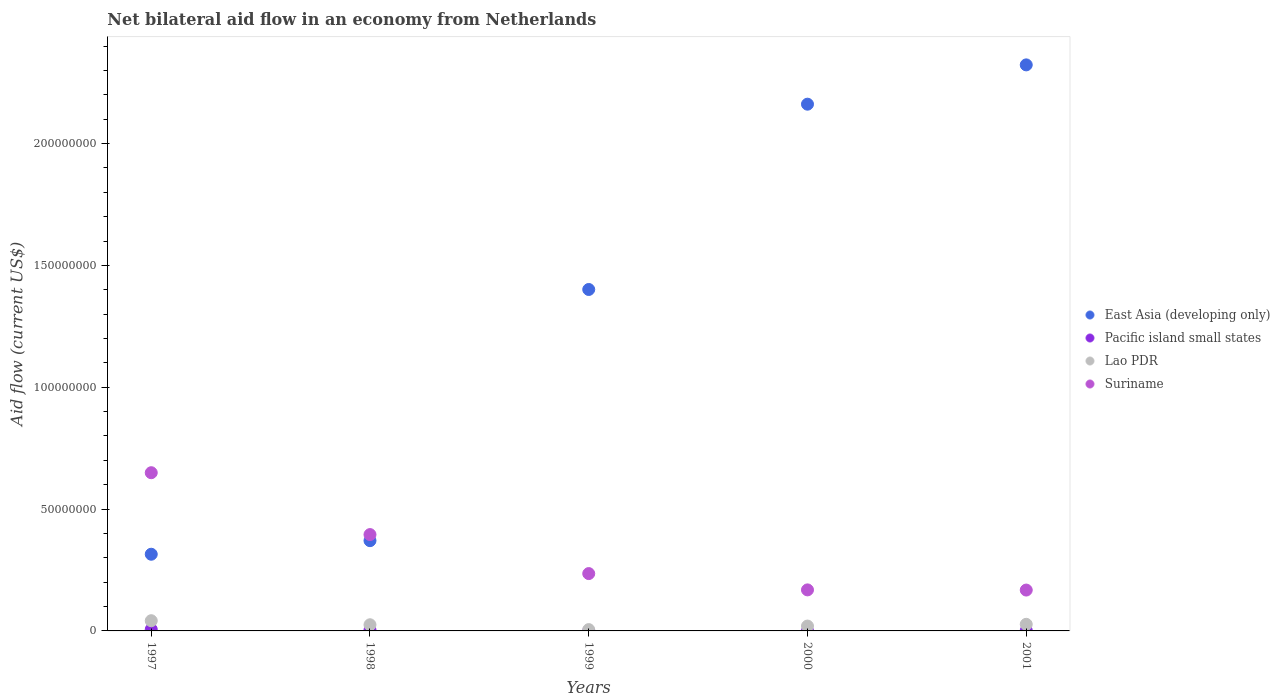What is the net bilateral aid flow in Suriname in 1998?
Make the answer very short. 3.95e+07. Across all years, what is the maximum net bilateral aid flow in Lao PDR?
Provide a short and direct response. 4.19e+06. Across all years, what is the minimum net bilateral aid flow in East Asia (developing only)?
Keep it short and to the point. 3.15e+07. What is the total net bilateral aid flow in Pacific island small states in the graph?
Provide a short and direct response. 1.22e+06. What is the difference between the net bilateral aid flow in Suriname in 1999 and that in 2000?
Your answer should be compact. 6.69e+06. What is the difference between the net bilateral aid flow in Pacific island small states in 1998 and the net bilateral aid flow in Suriname in 1999?
Provide a succinct answer. -2.31e+07. What is the average net bilateral aid flow in East Asia (developing only) per year?
Offer a terse response. 1.31e+08. In the year 1998, what is the difference between the net bilateral aid flow in Lao PDR and net bilateral aid flow in Suriname?
Your answer should be very brief. -3.70e+07. Is the difference between the net bilateral aid flow in Lao PDR in 1998 and 2000 greater than the difference between the net bilateral aid flow in Suriname in 1998 and 2000?
Give a very brief answer. No. What is the difference between the highest and the second highest net bilateral aid flow in Suriname?
Make the answer very short. 2.54e+07. What is the difference between the highest and the lowest net bilateral aid flow in Lao PDR?
Ensure brevity in your answer.  3.65e+06. In how many years, is the net bilateral aid flow in Suriname greater than the average net bilateral aid flow in Suriname taken over all years?
Your response must be concise. 2. Is it the case that in every year, the sum of the net bilateral aid flow in Lao PDR and net bilateral aid flow in Pacific island small states  is greater than the sum of net bilateral aid flow in Suriname and net bilateral aid flow in East Asia (developing only)?
Provide a succinct answer. No. Is the net bilateral aid flow in Suriname strictly greater than the net bilateral aid flow in Pacific island small states over the years?
Your response must be concise. Yes. Is the net bilateral aid flow in Pacific island small states strictly less than the net bilateral aid flow in Lao PDR over the years?
Your response must be concise. Yes. How many dotlines are there?
Give a very brief answer. 4. How many years are there in the graph?
Your answer should be very brief. 5. Are the values on the major ticks of Y-axis written in scientific E-notation?
Keep it short and to the point. No. Does the graph contain any zero values?
Give a very brief answer. Yes. Where does the legend appear in the graph?
Provide a short and direct response. Center right. What is the title of the graph?
Offer a very short reply. Net bilateral aid flow in an economy from Netherlands. Does "Mongolia" appear as one of the legend labels in the graph?
Offer a terse response. No. What is the label or title of the X-axis?
Make the answer very short. Years. What is the Aid flow (current US$) of East Asia (developing only) in 1997?
Your answer should be very brief. 3.15e+07. What is the Aid flow (current US$) in Pacific island small states in 1997?
Your answer should be very brief. 6.20e+05. What is the Aid flow (current US$) of Lao PDR in 1997?
Your answer should be compact. 4.19e+06. What is the Aid flow (current US$) of Suriname in 1997?
Give a very brief answer. 6.49e+07. What is the Aid flow (current US$) in East Asia (developing only) in 1998?
Offer a terse response. 3.70e+07. What is the Aid flow (current US$) in Lao PDR in 1998?
Your answer should be compact. 2.53e+06. What is the Aid flow (current US$) of Suriname in 1998?
Your answer should be compact. 3.95e+07. What is the Aid flow (current US$) of East Asia (developing only) in 1999?
Keep it short and to the point. 1.40e+08. What is the Aid flow (current US$) in Lao PDR in 1999?
Give a very brief answer. 5.40e+05. What is the Aid flow (current US$) of Suriname in 1999?
Keep it short and to the point. 2.35e+07. What is the Aid flow (current US$) of East Asia (developing only) in 2000?
Your answer should be very brief. 2.16e+08. What is the Aid flow (current US$) in Pacific island small states in 2000?
Offer a very short reply. 3.00e+04. What is the Aid flow (current US$) in Lao PDR in 2000?
Give a very brief answer. 1.99e+06. What is the Aid flow (current US$) of Suriname in 2000?
Make the answer very short. 1.68e+07. What is the Aid flow (current US$) of East Asia (developing only) in 2001?
Make the answer very short. 2.32e+08. What is the Aid flow (current US$) in Lao PDR in 2001?
Offer a very short reply. 2.71e+06. What is the Aid flow (current US$) in Suriname in 2001?
Offer a terse response. 1.68e+07. Across all years, what is the maximum Aid flow (current US$) of East Asia (developing only)?
Your answer should be very brief. 2.32e+08. Across all years, what is the maximum Aid flow (current US$) of Pacific island small states?
Keep it short and to the point. 6.20e+05. Across all years, what is the maximum Aid flow (current US$) of Lao PDR?
Offer a terse response. 4.19e+06. Across all years, what is the maximum Aid flow (current US$) in Suriname?
Provide a succinct answer. 6.49e+07. Across all years, what is the minimum Aid flow (current US$) of East Asia (developing only)?
Your response must be concise. 3.15e+07. Across all years, what is the minimum Aid flow (current US$) in Lao PDR?
Provide a short and direct response. 5.40e+05. Across all years, what is the minimum Aid flow (current US$) of Suriname?
Keep it short and to the point. 1.68e+07. What is the total Aid flow (current US$) in East Asia (developing only) in the graph?
Provide a short and direct response. 6.57e+08. What is the total Aid flow (current US$) in Pacific island small states in the graph?
Ensure brevity in your answer.  1.22e+06. What is the total Aid flow (current US$) of Lao PDR in the graph?
Ensure brevity in your answer.  1.20e+07. What is the total Aid flow (current US$) of Suriname in the graph?
Give a very brief answer. 1.62e+08. What is the difference between the Aid flow (current US$) of East Asia (developing only) in 1997 and that in 1998?
Offer a very short reply. -5.57e+06. What is the difference between the Aid flow (current US$) of Pacific island small states in 1997 and that in 1998?
Provide a succinct answer. 2.30e+05. What is the difference between the Aid flow (current US$) in Lao PDR in 1997 and that in 1998?
Your answer should be compact. 1.66e+06. What is the difference between the Aid flow (current US$) of Suriname in 1997 and that in 1998?
Your answer should be compact. 2.54e+07. What is the difference between the Aid flow (current US$) of East Asia (developing only) in 1997 and that in 1999?
Give a very brief answer. -1.09e+08. What is the difference between the Aid flow (current US$) of Lao PDR in 1997 and that in 1999?
Provide a short and direct response. 3.65e+06. What is the difference between the Aid flow (current US$) in Suriname in 1997 and that in 1999?
Keep it short and to the point. 4.14e+07. What is the difference between the Aid flow (current US$) of East Asia (developing only) in 1997 and that in 2000?
Provide a succinct answer. -1.85e+08. What is the difference between the Aid flow (current US$) in Pacific island small states in 1997 and that in 2000?
Provide a succinct answer. 5.90e+05. What is the difference between the Aid flow (current US$) of Lao PDR in 1997 and that in 2000?
Make the answer very short. 2.20e+06. What is the difference between the Aid flow (current US$) in Suriname in 1997 and that in 2000?
Offer a terse response. 4.81e+07. What is the difference between the Aid flow (current US$) in East Asia (developing only) in 1997 and that in 2001?
Your answer should be compact. -2.01e+08. What is the difference between the Aid flow (current US$) of Pacific island small states in 1997 and that in 2001?
Provide a succinct answer. 4.40e+05. What is the difference between the Aid flow (current US$) of Lao PDR in 1997 and that in 2001?
Keep it short and to the point. 1.48e+06. What is the difference between the Aid flow (current US$) of Suriname in 1997 and that in 2001?
Keep it short and to the point. 4.82e+07. What is the difference between the Aid flow (current US$) in East Asia (developing only) in 1998 and that in 1999?
Offer a terse response. -1.03e+08. What is the difference between the Aid flow (current US$) in Lao PDR in 1998 and that in 1999?
Make the answer very short. 1.99e+06. What is the difference between the Aid flow (current US$) of Suriname in 1998 and that in 1999?
Provide a succinct answer. 1.60e+07. What is the difference between the Aid flow (current US$) of East Asia (developing only) in 1998 and that in 2000?
Your response must be concise. -1.79e+08. What is the difference between the Aid flow (current US$) in Pacific island small states in 1998 and that in 2000?
Offer a terse response. 3.60e+05. What is the difference between the Aid flow (current US$) in Lao PDR in 1998 and that in 2000?
Your answer should be compact. 5.40e+05. What is the difference between the Aid flow (current US$) in Suriname in 1998 and that in 2000?
Make the answer very short. 2.27e+07. What is the difference between the Aid flow (current US$) in East Asia (developing only) in 1998 and that in 2001?
Give a very brief answer. -1.95e+08. What is the difference between the Aid flow (current US$) of Suriname in 1998 and that in 2001?
Your answer should be very brief. 2.28e+07. What is the difference between the Aid flow (current US$) of East Asia (developing only) in 1999 and that in 2000?
Your answer should be very brief. -7.60e+07. What is the difference between the Aid flow (current US$) of Lao PDR in 1999 and that in 2000?
Your answer should be very brief. -1.45e+06. What is the difference between the Aid flow (current US$) in Suriname in 1999 and that in 2000?
Your answer should be compact. 6.69e+06. What is the difference between the Aid flow (current US$) in East Asia (developing only) in 1999 and that in 2001?
Provide a short and direct response. -9.22e+07. What is the difference between the Aid flow (current US$) of Lao PDR in 1999 and that in 2001?
Provide a succinct answer. -2.17e+06. What is the difference between the Aid flow (current US$) of Suriname in 1999 and that in 2001?
Your response must be concise. 6.76e+06. What is the difference between the Aid flow (current US$) in East Asia (developing only) in 2000 and that in 2001?
Ensure brevity in your answer.  -1.61e+07. What is the difference between the Aid flow (current US$) of Pacific island small states in 2000 and that in 2001?
Provide a succinct answer. -1.50e+05. What is the difference between the Aid flow (current US$) in Lao PDR in 2000 and that in 2001?
Offer a terse response. -7.20e+05. What is the difference between the Aid flow (current US$) of East Asia (developing only) in 1997 and the Aid flow (current US$) of Pacific island small states in 1998?
Offer a very short reply. 3.11e+07. What is the difference between the Aid flow (current US$) in East Asia (developing only) in 1997 and the Aid flow (current US$) in Lao PDR in 1998?
Provide a succinct answer. 2.89e+07. What is the difference between the Aid flow (current US$) of East Asia (developing only) in 1997 and the Aid flow (current US$) of Suriname in 1998?
Give a very brief answer. -8.07e+06. What is the difference between the Aid flow (current US$) in Pacific island small states in 1997 and the Aid flow (current US$) in Lao PDR in 1998?
Your answer should be very brief. -1.91e+06. What is the difference between the Aid flow (current US$) in Pacific island small states in 1997 and the Aid flow (current US$) in Suriname in 1998?
Provide a short and direct response. -3.89e+07. What is the difference between the Aid flow (current US$) of Lao PDR in 1997 and the Aid flow (current US$) of Suriname in 1998?
Your answer should be very brief. -3.54e+07. What is the difference between the Aid flow (current US$) in East Asia (developing only) in 1997 and the Aid flow (current US$) in Lao PDR in 1999?
Your answer should be compact. 3.09e+07. What is the difference between the Aid flow (current US$) in East Asia (developing only) in 1997 and the Aid flow (current US$) in Suriname in 1999?
Your answer should be compact. 7.94e+06. What is the difference between the Aid flow (current US$) in Pacific island small states in 1997 and the Aid flow (current US$) in Lao PDR in 1999?
Keep it short and to the point. 8.00e+04. What is the difference between the Aid flow (current US$) in Pacific island small states in 1997 and the Aid flow (current US$) in Suriname in 1999?
Keep it short and to the point. -2.29e+07. What is the difference between the Aid flow (current US$) of Lao PDR in 1997 and the Aid flow (current US$) of Suriname in 1999?
Offer a terse response. -1.93e+07. What is the difference between the Aid flow (current US$) of East Asia (developing only) in 1997 and the Aid flow (current US$) of Pacific island small states in 2000?
Your answer should be very brief. 3.14e+07. What is the difference between the Aid flow (current US$) in East Asia (developing only) in 1997 and the Aid flow (current US$) in Lao PDR in 2000?
Ensure brevity in your answer.  2.95e+07. What is the difference between the Aid flow (current US$) of East Asia (developing only) in 1997 and the Aid flow (current US$) of Suriname in 2000?
Your response must be concise. 1.46e+07. What is the difference between the Aid flow (current US$) of Pacific island small states in 1997 and the Aid flow (current US$) of Lao PDR in 2000?
Your answer should be compact. -1.37e+06. What is the difference between the Aid flow (current US$) of Pacific island small states in 1997 and the Aid flow (current US$) of Suriname in 2000?
Your answer should be very brief. -1.62e+07. What is the difference between the Aid flow (current US$) of Lao PDR in 1997 and the Aid flow (current US$) of Suriname in 2000?
Make the answer very short. -1.26e+07. What is the difference between the Aid flow (current US$) of East Asia (developing only) in 1997 and the Aid flow (current US$) of Pacific island small states in 2001?
Offer a very short reply. 3.13e+07. What is the difference between the Aid flow (current US$) of East Asia (developing only) in 1997 and the Aid flow (current US$) of Lao PDR in 2001?
Provide a short and direct response. 2.88e+07. What is the difference between the Aid flow (current US$) in East Asia (developing only) in 1997 and the Aid flow (current US$) in Suriname in 2001?
Your response must be concise. 1.47e+07. What is the difference between the Aid flow (current US$) in Pacific island small states in 1997 and the Aid flow (current US$) in Lao PDR in 2001?
Offer a very short reply. -2.09e+06. What is the difference between the Aid flow (current US$) in Pacific island small states in 1997 and the Aid flow (current US$) in Suriname in 2001?
Provide a short and direct response. -1.62e+07. What is the difference between the Aid flow (current US$) of Lao PDR in 1997 and the Aid flow (current US$) of Suriname in 2001?
Keep it short and to the point. -1.26e+07. What is the difference between the Aid flow (current US$) of East Asia (developing only) in 1998 and the Aid flow (current US$) of Lao PDR in 1999?
Ensure brevity in your answer.  3.65e+07. What is the difference between the Aid flow (current US$) in East Asia (developing only) in 1998 and the Aid flow (current US$) in Suriname in 1999?
Keep it short and to the point. 1.35e+07. What is the difference between the Aid flow (current US$) of Pacific island small states in 1998 and the Aid flow (current US$) of Lao PDR in 1999?
Keep it short and to the point. -1.50e+05. What is the difference between the Aid flow (current US$) of Pacific island small states in 1998 and the Aid flow (current US$) of Suriname in 1999?
Provide a short and direct response. -2.31e+07. What is the difference between the Aid flow (current US$) of Lao PDR in 1998 and the Aid flow (current US$) of Suriname in 1999?
Your answer should be very brief. -2.10e+07. What is the difference between the Aid flow (current US$) in East Asia (developing only) in 1998 and the Aid flow (current US$) in Pacific island small states in 2000?
Offer a terse response. 3.70e+07. What is the difference between the Aid flow (current US$) in East Asia (developing only) in 1998 and the Aid flow (current US$) in Lao PDR in 2000?
Offer a very short reply. 3.50e+07. What is the difference between the Aid flow (current US$) in East Asia (developing only) in 1998 and the Aid flow (current US$) in Suriname in 2000?
Your answer should be compact. 2.02e+07. What is the difference between the Aid flow (current US$) in Pacific island small states in 1998 and the Aid flow (current US$) in Lao PDR in 2000?
Your answer should be compact. -1.60e+06. What is the difference between the Aid flow (current US$) in Pacific island small states in 1998 and the Aid flow (current US$) in Suriname in 2000?
Make the answer very short. -1.64e+07. What is the difference between the Aid flow (current US$) in Lao PDR in 1998 and the Aid flow (current US$) in Suriname in 2000?
Ensure brevity in your answer.  -1.43e+07. What is the difference between the Aid flow (current US$) of East Asia (developing only) in 1998 and the Aid flow (current US$) of Pacific island small states in 2001?
Your answer should be compact. 3.69e+07. What is the difference between the Aid flow (current US$) of East Asia (developing only) in 1998 and the Aid flow (current US$) of Lao PDR in 2001?
Keep it short and to the point. 3.43e+07. What is the difference between the Aid flow (current US$) in East Asia (developing only) in 1998 and the Aid flow (current US$) in Suriname in 2001?
Make the answer very short. 2.03e+07. What is the difference between the Aid flow (current US$) of Pacific island small states in 1998 and the Aid flow (current US$) of Lao PDR in 2001?
Your answer should be compact. -2.32e+06. What is the difference between the Aid flow (current US$) in Pacific island small states in 1998 and the Aid flow (current US$) in Suriname in 2001?
Your answer should be compact. -1.64e+07. What is the difference between the Aid flow (current US$) of Lao PDR in 1998 and the Aid flow (current US$) of Suriname in 2001?
Make the answer very short. -1.42e+07. What is the difference between the Aid flow (current US$) in East Asia (developing only) in 1999 and the Aid flow (current US$) in Pacific island small states in 2000?
Your answer should be compact. 1.40e+08. What is the difference between the Aid flow (current US$) in East Asia (developing only) in 1999 and the Aid flow (current US$) in Lao PDR in 2000?
Give a very brief answer. 1.38e+08. What is the difference between the Aid flow (current US$) in East Asia (developing only) in 1999 and the Aid flow (current US$) in Suriname in 2000?
Provide a succinct answer. 1.23e+08. What is the difference between the Aid flow (current US$) of Lao PDR in 1999 and the Aid flow (current US$) of Suriname in 2000?
Offer a very short reply. -1.63e+07. What is the difference between the Aid flow (current US$) in East Asia (developing only) in 1999 and the Aid flow (current US$) in Pacific island small states in 2001?
Provide a succinct answer. 1.40e+08. What is the difference between the Aid flow (current US$) in East Asia (developing only) in 1999 and the Aid flow (current US$) in Lao PDR in 2001?
Give a very brief answer. 1.37e+08. What is the difference between the Aid flow (current US$) of East Asia (developing only) in 1999 and the Aid flow (current US$) of Suriname in 2001?
Your answer should be compact. 1.23e+08. What is the difference between the Aid flow (current US$) in Lao PDR in 1999 and the Aid flow (current US$) in Suriname in 2001?
Your response must be concise. -1.62e+07. What is the difference between the Aid flow (current US$) in East Asia (developing only) in 2000 and the Aid flow (current US$) in Pacific island small states in 2001?
Give a very brief answer. 2.16e+08. What is the difference between the Aid flow (current US$) in East Asia (developing only) in 2000 and the Aid flow (current US$) in Lao PDR in 2001?
Keep it short and to the point. 2.13e+08. What is the difference between the Aid flow (current US$) of East Asia (developing only) in 2000 and the Aid flow (current US$) of Suriname in 2001?
Offer a terse response. 1.99e+08. What is the difference between the Aid flow (current US$) of Pacific island small states in 2000 and the Aid flow (current US$) of Lao PDR in 2001?
Provide a short and direct response. -2.68e+06. What is the difference between the Aid flow (current US$) in Pacific island small states in 2000 and the Aid flow (current US$) in Suriname in 2001?
Provide a short and direct response. -1.67e+07. What is the difference between the Aid flow (current US$) of Lao PDR in 2000 and the Aid flow (current US$) of Suriname in 2001?
Provide a short and direct response. -1.48e+07. What is the average Aid flow (current US$) in East Asia (developing only) per year?
Your answer should be compact. 1.31e+08. What is the average Aid flow (current US$) in Pacific island small states per year?
Provide a short and direct response. 2.44e+05. What is the average Aid flow (current US$) in Lao PDR per year?
Your answer should be compact. 2.39e+06. What is the average Aid flow (current US$) in Suriname per year?
Your answer should be very brief. 3.23e+07. In the year 1997, what is the difference between the Aid flow (current US$) in East Asia (developing only) and Aid flow (current US$) in Pacific island small states?
Ensure brevity in your answer.  3.08e+07. In the year 1997, what is the difference between the Aid flow (current US$) of East Asia (developing only) and Aid flow (current US$) of Lao PDR?
Your answer should be compact. 2.73e+07. In the year 1997, what is the difference between the Aid flow (current US$) of East Asia (developing only) and Aid flow (current US$) of Suriname?
Provide a succinct answer. -3.35e+07. In the year 1997, what is the difference between the Aid flow (current US$) in Pacific island small states and Aid flow (current US$) in Lao PDR?
Your answer should be compact. -3.57e+06. In the year 1997, what is the difference between the Aid flow (current US$) in Pacific island small states and Aid flow (current US$) in Suriname?
Offer a terse response. -6.43e+07. In the year 1997, what is the difference between the Aid flow (current US$) of Lao PDR and Aid flow (current US$) of Suriname?
Keep it short and to the point. -6.07e+07. In the year 1998, what is the difference between the Aid flow (current US$) of East Asia (developing only) and Aid flow (current US$) of Pacific island small states?
Your answer should be very brief. 3.66e+07. In the year 1998, what is the difference between the Aid flow (current US$) in East Asia (developing only) and Aid flow (current US$) in Lao PDR?
Your response must be concise. 3.45e+07. In the year 1998, what is the difference between the Aid flow (current US$) of East Asia (developing only) and Aid flow (current US$) of Suriname?
Offer a terse response. -2.50e+06. In the year 1998, what is the difference between the Aid flow (current US$) in Pacific island small states and Aid flow (current US$) in Lao PDR?
Keep it short and to the point. -2.14e+06. In the year 1998, what is the difference between the Aid flow (current US$) of Pacific island small states and Aid flow (current US$) of Suriname?
Keep it short and to the point. -3.92e+07. In the year 1998, what is the difference between the Aid flow (current US$) of Lao PDR and Aid flow (current US$) of Suriname?
Make the answer very short. -3.70e+07. In the year 1999, what is the difference between the Aid flow (current US$) of East Asia (developing only) and Aid flow (current US$) of Lao PDR?
Offer a very short reply. 1.40e+08. In the year 1999, what is the difference between the Aid flow (current US$) in East Asia (developing only) and Aid flow (current US$) in Suriname?
Give a very brief answer. 1.17e+08. In the year 1999, what is the difference between the Aid flow (current US$) of Lao PDR and Aid flow (current US$) of Suriname?
Your response must be concise. -2.30e+07. In the year 2000, what is the difference between the Aid flow (current US$) in East Asia (developing only) and Aid flow (current US$) in Pacific island small states?
Your answer should be very brief. 2.16e+08. In the year 2000, what is the difference between the Aid flow (current US$) in East Asia (developing only) and Aid flow (current US$) in Lao PDR?
Make the answer very short. 2.14e+08. In the year 2000, what is the difference between the Aid flow (current US$) in East Asia (developing only) and Aid flow (current US$) in Suriname?
Provide a succinct answer. 1.99e+08. In the year 2000, what is the difference between the Aid flow (current US$) in Pacific island small states and Aid flow (current US$) in Lao PDR?
Ensure brevity in your answer.  -1.96e+06. In the year 2000, what is the difference between the Aid flow (current US$) in Pacific island small states and Aid flow (current US$) in Suriname?
Your answer should be compact. -1.68e+07. In the year 2000, what is the difference between the Aid flow (current US$) in Lao PDR and Aid flow (current US$) in Suriname?
Your answer should be very brief. -1.48e+07. In the year 2001, what is the difference between the Aid flow (current US$) of East Asia (developing only) and Aid flow (current US$) of Pacific island small states?
Keep it short and to the point. 2.32e+08. In the year 2001, what is the difference between the Aid flow (current US$) in East Asia (developing only) and Aid flow (current US$) in Lao PDR?
Provide a short and direct response. 2.30e+08. In the year 2001, what is the difference between the Aid flow (current US$) of East Asia (developing only) and Aid flow (current US$) of Suriname?
Your answer should be very brief. 2.16e+08. In the year 2001, what is the difference between the Aid flow (current US$) in Pacific island small states and Aid flow (current US$) in Lao PDR?
Your answer should be compact. -2.53e+06. In the year 2001, what is the difference between the Aid flow (current US$) in Pacific island small states and Aid flow (current US$) in Suriname?
Keep it short and to the point. -1.66e+07. In the year 2001, what is the difference between the Aid flow (current US$) in Lao PDR and Aid flow (current US$) in Suriname?
Give a very brief answer. -1.41e+07. What is the ratio of the Aid flow (current US$) of East Asia (developing only) in 1997 to that in 1998?
Provide a succinct answer. 0.85. What is the ratio of the Aid flow (current US$) in Pacific island small states in 1997 to that in 1998?
Provide a succinct answer. 1.59. What is the ratio of the Aid flow (current US$) of Lao PDR in 1997 to that in 1998?
Offer a terse response. 1.66. What is the ratio of the Aid flow (current US$) of Suriname in 1997 to that in 1998?
Offer a terse response. 1.64. What is the ratio of the Aid flow (current US$) in East Asia (developing only) in 1997 to that in 1999?
Provide a short and direct response. 0.22. What is the ratio of the Aid flow (current US$) in Lao PDR in 1997 to that in 1999?
Your answer should be compact. 7.76. What is the ratio of the Aid flow (current US$) in Suriname in 1997 to that in 1999?
Offer a very short reply. 2.76. What is the ratio of the Aid flow (current US$) of East Asia (developing only) in 1997 to that in 2000?
Offer a terse response. 0.15. What is the ratio of the Aid flow (current US$) of Pacific island small states in 1997 to that in 2000?
Make the answer very short. 20.67. What is the ratio of the Aid flow (current US$) in Lao PDR in 1997 to that in 2000?
Make the answer very short. 2.11. What is the ratio of the Aid flow (current US$) of Suriname in 1997 to that in 2000?
Offer a very short reply. 3.86. What is the ratio of the Aid flow (current US$) in East Asia (developing only) in 1997 to that in 2001?
Your response must be concise. 0.14. What is the ratio of the Aid flow (current US$) of Pacific island small states in 1997 to that in 2001?
Keep it short and to the point. 3.44. What is the ratio of the Aid flow (current US$) of Lao PDR in 1997 to that in 2001?
Provide a succinct answer. 1.55. What is the ratio of the Aid flow (current US$) in Suriname in 1997 to that in 2001?
Give a very brief answer. 3.87. What is the ratio of the Aid flow (current US$) in East Asia (developing only) in 1998 to that in 1999?
Make the answer very short. 0.26. What is the ratio of the Aid flow (current US$) in Lao PDR in 1998 to that in 1999?
Your answer should be compact. 4.69. What is the ratio of the Aid flow (current US$) of Suriname in 1998 to that in 1999?
Your answer should be very brief. 1.68. What is the ratio of the Aid flow (current US$) of East Asia (developing only) in 1998 to that in 2000?
Your answer should be compact. 0.17. What is the ratio of the Aid flow (current US$) of Pacific island small states in 1998 to that in 2000?
Make the answer very short. 13. What is the ratio of the Aid flow (current US$) in Lao PDR in 1998 to that in 2000?
Give a very brief answer. 1.27. What is the ratio of the Aid flow (current US$) in Suriname in 1998 to that in 2000?
Give a very brief answer. 2.35. What is the ratio of the Aid flow (current US$) of East Asia (developing only) in 1998 to that in 2001?
Ensure brevity in your answer.  0.16. What is the ratio of the Aid flow (current US$) in Pacific island small states in 1998 to that in 2001?
Your answer should be compact. 2.17. What is the ratio of the Aid flow (current US$) in Lao PDR in 1998 to that in 2001?
Offer a very short reply. 0.93. What is the ratio of the Aid flow (current US$) in Suriname in 1998 to that in 2001?
Give a very brief answer. 2.36. What is the ratio of the Aid flow (current US$) in East Asia (developing only) in 1999 to that in 2000?
Offer a terse response. 0.65. What is the ratio of the Aid flow (current US$) of Lao PDR in 1999 to that in 2000?
Offer a very short reply. 0.27. What is the ratio of the Aid flow (current US$) in Suriname in 1999 to that in 2000?
Give a very brief answer. 1.4. What is the ratio of the Aid flow (current US$) in East Asia (developing only) in 1999 to that in 2001?
Your answer should be compact. 0.6. What is the ratio of the Aid flow (current US$) of Lao PDR in 1999 to that in 2001?
Your response must be concise. 0.2. What is the ratio of the Aid flow (current US$) in Suriname in 1999 to that in 2001?
Your response must be concise. 1.4. What is the ratio of the Aid flow (current US$) in East Asia (developing only) in 2000 to that in 2001?
Offer a very short reply. 0.93. What is the ratio of the Aid flow (current US$) in Pacific island small states in 2000 to that in 2001?
Offer a terse response. 0.17. What is the ratio of the Aid flow (current US$) of Lao PDR in 2000 to that in 2001?
Your answer should be compact. 0.73. What is the ratio of the Aid flow (current US$) of Suriname in 2000 to that in 2001?
Keep it short and to the point. 1. What is the difference between the highest and the second highest Aid flow (current US$) in East Asia (developing only)?
Give a very brief answer. 1.61e+07. What is the difference between the highest and the second highest Aid flow (current US$) in Lao PDR?
Make the answer very short. 1.48e+06. What is the difference between the highest and the second highest Aid flow (current US$) of Suriname?
Ensure brevity in your answer.  2.54e+07. What is the difference between the highest and the lowest Aid flow (current US$) in East Asia (developing only)?
Provide a short and direct response. 2.01e+08. What is the difference between the highest and the lowest Aid flow (current US$) in Pacific island small states?
Your response must be concise. 6.20e+05. What is the difference between the highest and the lowest Aid flow (current US$) in Lao PDR?
Offer a very short reply. 3.65e+06. What is the difference between the highest and the lowest Aid flow (current US$) of Suriname?
Offer a terse response. 4.82e+07. 